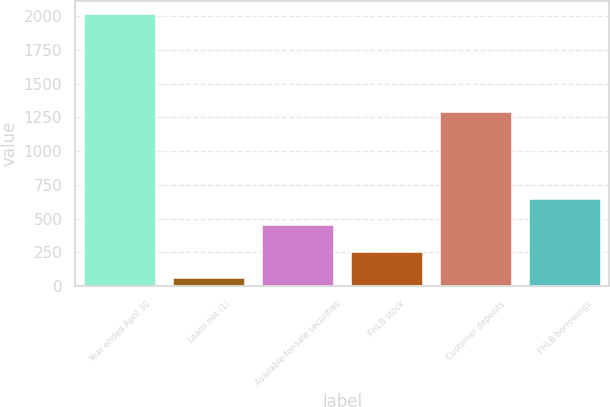Convert chart to OTSL. <chart><loc_0><loc_0><loc_500><loc_500><bar_chart><fcel>Year ended April 30<fcel>Loans net (1)<fcel>Available-for-sale securities<fcel>FHLB stock<fcel>Customer deposits<fcel>FHLB borrowings<nl><fcel>2013<fcel>60<fcel>450.6<fcel>255.3<fcel>1286<fcel>645.9<nl></chart> 